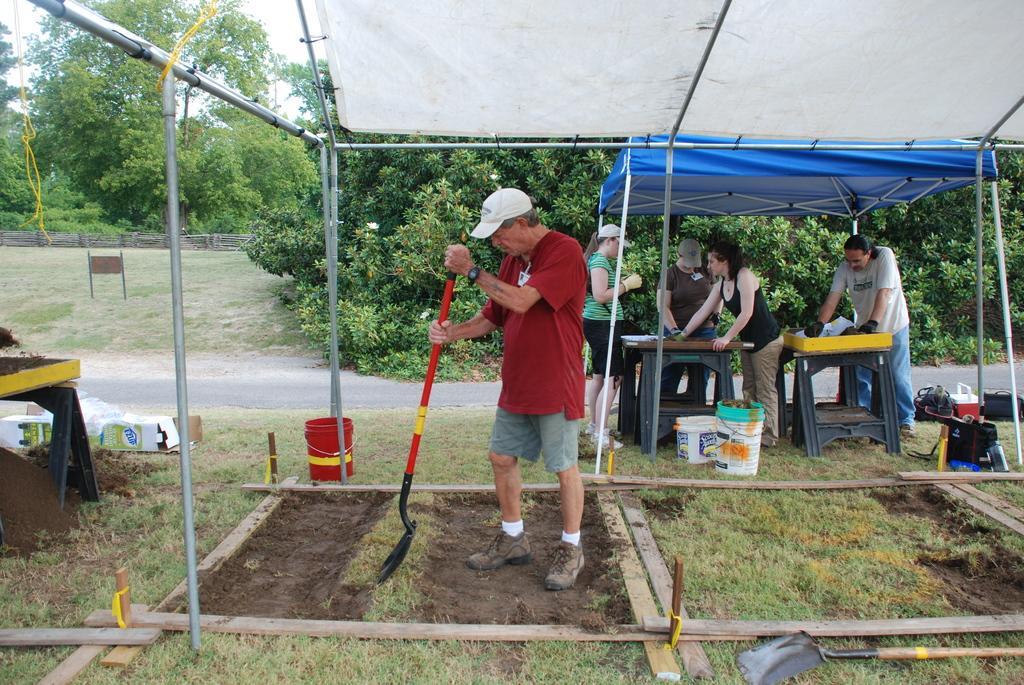Could you give a brief overview of what you see in this image? In this picture I can see trees in the background. I can see green grass. I can see a person holding the metal object on the left side. I can see a few people standing on the right side. I can see the tents. I can see the road. I can see the tables. I can see wooden fence. 